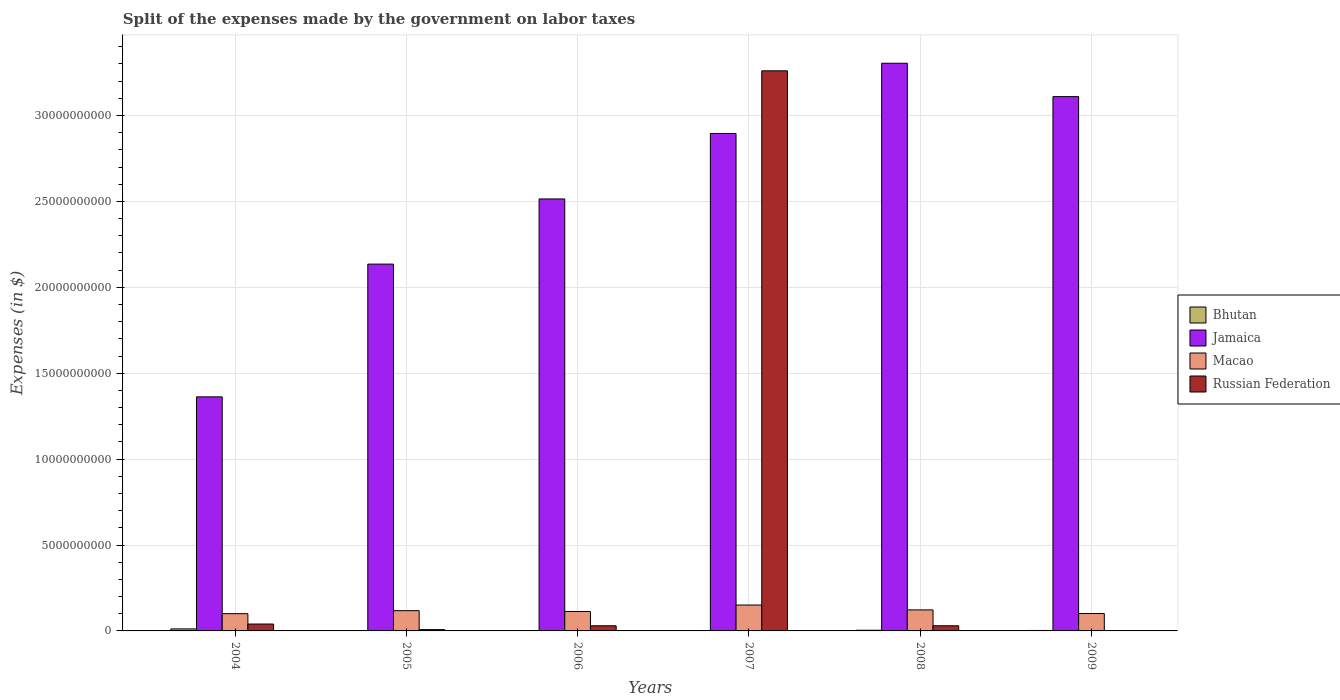Are the number of bars on each tick of the X-axis equal?
Ensure brevity in your answer.  No. What is the expenses made by the government on labor taxes in Jamaica in 2006?
Offer a terse response. 2.51e+1. Across all years, what is the maximum expenses made by the government on labor taxes in Jamaica?
Give a very brief answer. 3.30e+1. Across all years, what is the minimum expenses made by the government on labor taxes in Macao?
Keep it short and to the point. 1.00e+09. In which year was the expenses made by the government on labor taxes in Macao maximum?
Your response must be concise. 2007. What is the total expenses made by the government on labor taxes in Bhutan in the graph?
Ensure brevity in your answer.  2.32e+08. What is the difference between the expenses made by the government on labor taxes in Bhutan in 2004 and that in 2006?
Provide a short and direct response. 1.05e+08. What is the difference between the expenses made by the government on labor taxes in Russian Federation in 2007 and the expenses made by the government on labor taxes in Macao in 2008?
Keep it short and to the point. 3.14e+1. What is the average expenses made by the government on labor taxes in Russian Federation per year?
Provide a short and direct response. 5.61e+09. In the year 2004, what is the difference between the expenses made by the government on labor taxes in Bhutan and expenses made by the government on labor taxes in Jamaica?
Keep it short and to the point. -1.35e+1. In how many years, is the expenses made by the government on labor taxes in Macao greater than 28000000000 $?
Make the answer very short. 0. What is the ratio of the expenses made by the government on labor taxes in Macao in 2004 to that in 2009?
Your response must be concise. 0.99. Is the expenses made by the government on labor taxes in Jamaica in 2005 less than that in 2008?
Offer a very short reply. Yes. What is the difference between the highest and the second highest expenses made by the government on labor taxes in Macao?
Offer a very short reply. 2.83e+08. What is the difference between the highest and the lowest expenses made by the government on labor taxes in Jamaica?
Provide a short and direct response. 1.94e+1. Is it the case that in every year, the sum of the expenses made by the government on labor taxes in Bhutan and expenses made by the government on labor taxes in Macao is greater than the expenses made by the government on labor taxes in Jamaica?
Keep it short and to the point. No. How many bars are there?
Offer a very short reply. 23. Are all the bars in the graph horizontal?
Provide a succinct answer. No. How many years are there in the graph?
Offer a very short reply. 6. What is the difference between two consecutive major ticks on the Y-axis?
Your answer should be compact. 5.00e+09. How are the legend labels stacked?
Give a very brief answer. Vertical. What is the title of the graph?
Provide a succinct answer. Split of the expenses made by the government on labor taxes. Does "Dominica" appear as one of the legend labels in the graph?
Offer a very short reply. No. What is the label or title of the Y-axis?
Provide a succinct answer. Expenses (in $). What is the Expenses (in $) in Bhutan in 2004?
Keep it short and to the point. 1.18e+08. What is the Expenses (in $) of Jamaica in 2004?
Make the answer very short. 1.36e+1. What is the Expenses (in $) in Macao in 2004?
Your answer should be compact. 1.00e+09. What is the Expenses (in $) in Russian Federation in 2004?
Provide a short and direct response. 4.01e+08. What is the Expenses (in $) of Bhutan in 2005?
Keep it short and to the point. 1.28e+07. What is the Expenses (in $) of Jamaica in 2005?
Give a very brief answer. 2.14e+1. What is the Expenses (in $) in Macao in 2005?
Give a very brief answer. 1.18e+09. What is the Expenses (in $) in Russian Federation in 2005?
Offer a very short reply. 7.50e+07. What is the Expenses (in $) in Bhutan in 2006?
Your response must be concise. 1.35e+07. What is the Expenses (in $) of Jamaica in 2006?
Offer a terse response. 2.51e+1. What is the Expenses (in $) in Macao in 2006?
Provide a short and direct response. 1.13e+09. What is the Expenses (in $) of Russian Federation in 2006?
Your response must be concise. 3.00e+08. What is the Expenses (in $) of Bhutan in 2007?
Offer a terse response. 2.20e+07. What is the Expenses (in $) in Jamaica in 2007?
Offer a very short reply. 2.90e+1. What is the Expenses (in $) in Macao in 2007?
Your answer should be compact. 1.51e+09. What is the Expenses (in $) of Russian Federation in 2007?
Offer a terse response. 3.26e+1. What is the Expenses (in $) in Bhutan in 2008?
Keep it short and to the point. 3.87e+07. What is the Expenses (in $) of Jamaica in 2008?
Make the answer very short. 3.30e+1. What is the Expenses (in $) in Macao in 2008?
Your answer should be very brief. 1.22e+09. What is the Expenses (in $) of Russian Federation in 2008?
Ensure brevity in your answer.  3.00e+08. What is the Expenses (in $) in Bhutan in 2009?
Give a very brief answer. 2.65e+07. What is the Expenses (in $) of Jamaica in 2009?
Your response must be concise. 3.11e+1. What is the Expenses (in $) of Macao in 2009?
Offer a terse response. 1.01e+09. What is the Expenses (in $) of Russian Federation in 2009?
Offer a terse response. 0. Across all years, what is the maximum Expenses (in $) of Bhutan?
Make the answer very short. 1.18e+08. Across all years, what is the maximum Expenses (in $) in Jamaica?
Give a very brief answer. 3.30e+1. Across all years, what is the maximum Expenses (in $) in Macao?
Your answer should be very brief. 1.51e+09. Across all years, what is the maximum Expenses (in $) of Russian Federation?
Keep it short and to the point. 3.26e+1. Across all years, what is the minimum Expenses (in $) of Bhutan?
Offer a very short reply. 1.28e+07. Across all years, what is the minimum Expenses (in $) of Jamaica?
Make the answer very short. 1.36e+1. Across all years, what is the minimum Expenses (in $) in Macao?
Offer a very short reply. 1.00e+09. Across all years, what is the minimum Expenses (in $) of Russian Federation?
Your answer should be very brief. 0. What is the total Expenses (in $) of Bhutan in the graph?
Keep it short and to the point. 2.32e+08. What is the total Expenses (in $) of Jamaica in the graph?
Provide a succinct answer. 1.53e+11. What is the total Expenses (in $) of Macao in the graph?
Keep it short and to the point. 7.06e+09. What is the total Expenses (in $) in Russian Federation in the graph?
Your answer should be very brief. 3.37e+1. What is the difference between the Expenses (in $) in Bhutan in 2004 and that in 2005?
Offer a terse response. 1.05e+08. What is the difference between the Expenses (in $) of Jamaica in 2004 and that in 2005?
Your response must be concise. -7.73e+09. What is the difference between the Expenses (in $) of Macao in 2004 and that in 2005?
Provide a short and direct response. -1.74e+08. What is the difference between the Expenses (in $) in Russian Federation in 2004 and that in 2005?
Provide a succinct answer. 3.26e+08. What is the difference between the Expenses (in $) in Bhutan in 2004 and that in 2006?
Provide a short and direct response. 1.05e+08. What is the difference between the Expenses (in $) of Jamaica in 2004 and that in 2006?
Provide a short and direct response. -1.15e+1. What is the difference between the Expenses (in $) of Macao in 2004 and that in 2006?
Ensure brevity in your answer.  -1.26e+08. What is the difference between the Expenses (in $) of Russian Federation in 2004 and that in 2006?
Give a very brief answer. 1.01e+08. What is the difference between the Expenses (in $) of Bhutan in 2004 and that in 2007?
Your answer should be very brief. 9.61e+07. What is the difference between the Expenses (in $) of Jamaica in 2004 and that in 2007?
Give a very brief answer. -1.53e+1. What is the difference between the Expenses (in $) of Macao in 2004 and that in 2007?
Your response must be concise. -5.03e+08. What is the difference between the Expenses (in $) in Russian Federation in 2004 and that in 2007?
Make the answer very short. -3.22e+1. What is the difference between the Expenses (in $) of Bhutan in 2004 and that in 2008?
Offer a very short reply. 7.95e+07. What is the difference between the Expenses (in $) of Jamaica in 2004 and that in 2008?
Keep it short and to the point. -1.94e+1. What is the difference between the Expenses (in $) of Macao in 2004 and that in 2008?
Give a very brief answer. -2.19e+08. What is the difference between the Expenses (in $) in Russian Federation in 2004 and that in 2008?
Provide a short and direct response. 1.01e+08. What is the difference between the Expenses (in $) of Bhutan in 2004 and that in 2009?
Make the answer very short. 9.17e+07. What is the difference between the Expenses (in $) in Jamaica in 2004 and that in 2009?
Your answer should be compact. -1.75e+1. What is the difference between the Expenses (in $) in Macao in 2004 and that in 2009?
Provide a short and direct response. -8.64e+06. What is the difference between the Expenses (in $) in Bhutan in 2005 and that in 2006?
Keep it short and to the point. -6.82e+05. What is the difference between the Expenses (in $) in Jamaica in 2005 and that in 2006?
Your answer should be very brief. -3.79e+09. What is the difference between the Expenses (in $) of Macao in 2005 and that in 2006?
Offer a terse response. 4.80e+07. What is the difference between the Expenses (in $) in Russian Federation in 2005 and that in 2006?
Your response must be concise. -2.25e+08. What is the difference between the Expenses (in $) in Bhutan in 2005 and that in 2007?
Ensure brevity in your answer.  -9.28e+06. What is the difference between the Expenses (in $) of Jamaica in 2005 and that in 2007?
Provide a succinct answer. -7.60e+09. What is the difference between the Expenses (in $) of Macao in 2005 and that in 2007?
Give a very brief answer. -3.28e+08. What is the difference between the Expenses (in $) of Russian Federation in 2005 and that in 2007?
Ensure brevity in your answer.  -3.25e+1. What is the difference between the Expenses (in $) in Bhutan in 2005 and that in 2008?
Your answer should be very brief. -2.59e+07. What is the difference between the Expenses (in $) in Jamaica in 2005 and that in 2008?
Keep it short and to the point. -1.17e+1. What is the difference between the Expenses (in $) of Macao in 2005 and that in 2008?
Keep it short and to the point. -4.48e+07. What is the difference between the Expenses (in $) of Russian Federation in 2005 and that in 2008?
Your answer should be compact. -2.25e+08. What is the difference between the Expenses (in $) in Bhutan in 2005 and that in 2009?
Provide a succinct answer. -1.37e+07. What is the difference between the Expenses (in $) of Jamaica in 2005 and that in 2009?
Keep it short and to the point. -9.75e+09. What is the difference between the Expenses (in $) of Macao in 2005 and that in 2009?
Offer a very short reply. 1.66e+08. What is the difference between the Expenses (in $) in Bhutan in 2006 and that in 2007?
Offer a very short reply. -8.59e+06. What is the difference between the Expenses (in $) in Jamaica in 2006 and that in 2007?
Ensure brevity in your answer.  -3.81e+09. What is the difference between the Expenses (in $) in Macao in 2006 and that in 2007?
Your answer should be very brief. -3.76e+08. What is the difference between the Expenses (in $) in Russian Federation in 2006 and that in 2007?
Ensure brevity in your answer.  -3.23e+1. What is the difference between the Expenses (in $) in Bhutan in 2006 and that in 2008?
Your answer should be compact. -2.52e+07. What is the difference between the Expenses (in $) of Jamaica in 2006 and that in 2008?
Your answer should be very brief. -7.90e+09. What is the difference between the Expenses (in $) in Macao in 2006 and that in 2008?
Your response must be concise. -9.28e+07. What is the difference between the Expenses (in $) in Bhutan in 2006 and that in 2009?
Your answer should be very brief. -1.30e+07. What is the difference between the Expenses (in $) of Jamaica in 2006 and that in 2009?
Your answer should be very brief. -5.96e+09. What is the difference between the Expenses (in $) of Macao in 2006 and that in 2009?
Give a very brief answer. 1.18e+08. What is the difference between the Expenses (in $) of Bhutan in 2007 and that in 2008?
Offer a terse response. -1.66e+07. What is the difference between the Expenses (in $) of Jamaica in 2007 and that in 2008?
Your answer should be compact. -4.09e+09. What is the difference between the Expenses (in $) in Macao in 2007 and that in 2008?
Your response must be concise. 2.83e+08. What is the difference between the Expenses (in $) of Russian Federation in 2007 and that in 2008?
Give a very brief answer. 3.23e+1. What is the difference between the Expenses (in $) in Bhutan in 2007 and that in 2009?
Ensure brevity in your answer.  -4.44e+06. What is the difference between the Expenses (in $) in Jamaica in 2007 and that in 2009?
Provide a succinct answer. -2.14e+09. What is the difference between the Expenses (in $) of Macao in 2007 and that in 2009?
Offer a terse response. 4.94e+08. What is the difference between the Expenses (in $) of Bhutan in 2008 and that in 2009?
Your answer should be very brief. 1.22e+07. What is the difference between the Expenses (in $) of Jamaica in 2008 and that in 2009?
Ensure brevity in your answer.  1.94e+09. What is the difference between the Expenses (in $) in Macao in 2008 and that in 2009?
Provide a succinct answer. 2.11e+08. What is the difference between the Expenses (in $) in Bhutan in 2004 and the Expenses (in $) in Jamaica in 2005?
Ensure brevity in your answer.  -2.12e+1. What is the difference between the Expenses (in $) in Bhutan in 2004 and the Expenses (in $) in Macao in 2005?
Your answer should be compact. -1.06e+09. What is the difference between the Expenses (in $) in Bhutan in 2004 and the Expenses (in $) in Russian Federation in 2005?
Ensure brevity in your answer.  4.32e+07. What is the difference between the Expenses (in $) in Jamaica in 2004 and the Expenses (in $) in Macao in 2005?
Your answer should be compact. 1.24e+1. What is the difference between the Expenses (in $) of Jamaica in 2004 and the Expenses (in $) of Russian Federation in 2005?
Your response must be concise. 1.35e+1. What is the difference between the Expenses (in $) of Macao in 2004 and the Expenses (in $) of Russian Federation in 2005?
Ensure brevity in your answer.  9.30e+08. What is the difference between the Expenses (in $) in Bhutan in 2004 and the Expenses (in $) in Jamaica in 2006?
Make the answer very short. -2.50e+1. What is the difference between the Expenses (in $) in Bhutan in 2004 and the Expenses (in $) in Macao in 2006?
Your response must be concise. -1.01e+09. What is the difference between the Expenses (in $) in Bhutan in 2004 and the Expenses (in $) in Russian Federation in 2006?
Offer a terse response. -1.82e+08. What is the difference between the Expenses (in $) of Jamaica in 2004 and the Expenses (in $) of Macao in 2006?
Provide a succinct answer. 1.25e+1. What is the difference between the Expenses (in $) of Jamaica in 2004 and the Expenses (in $) of Russian Federation in 2006?
Offer a terse response. 1.33e+1. What is the difference between the Expenses (in $) of Macao in 2004 and the Expenses (in $) of Russian Federation in 2006?
Give a very brief answer. 7.05e+08. What is the difference between the Expenses (in $) of Bhutan in 2004 and the Expenses (in $) of Jamaica in 2007?
Ensure brevity in your answer.  -2.88e+1. What is the difference between the Expenses (in $) in Bhutan in 2004 and the Expenses (in $) in Macao in 2007?
Offer a terse response. -1.39e+09. What is the difference between the Expenses (in $) in Bhutan in 2004 and the Expenses (in $) in Russian Federation in 2007?
Your answer should be compact. -3.25e+1. What is the difference between the Expenses (in $) of Jamaica in 2004 and the Expenses (in $) of Macao in 2007?
Your answer should be very brief. 1.21e+1. What is the difference between the Expenses (in $) in Jamaica in 2004 and the Expenses (in $) in Russian Federation in 2007?
Give a very brief answer. -1.90e+1. What is the difference between the Expenses (in $) of Macao in 2004 and the Expenses (in $) of Russian Federation in 2007?
Provide a succinct answer. -3.16e+1. What is the difference between the Expenses (in $) in Bhutan in 2004 and the Expenses (in $) in Jamaica in 2008?
Provide a succinct answer. -3.29e+1. What is the difference between the Expenses (in $) in Bhutan in 2004 and the Expenses (in $) in Macao in 2008?
Provide a short and direct response. -1.11e+09. What is the difference between the Expenses (in $) in Bhutan in 2004 and the Expenses (in $) in Russian Federation in 2008?
Offer a terse response. -1.82e+08. What is the difference between the Expenses (in $) of Jamaica in 2004 and the Expenses (in $) of Macao in 2008?
Provide a short and direct response. 1.24e+1. What is the difference between the Expenses (in $) of Jamaica in 2004 and the Expenses (in $) of Russian Federation in 2008?
Offer a very short reply. 1.33e+1. What is the difference between the Expenses (in $) in Macao in 2004 and the Expenses (in $) in Russian Federation in 2008?
Your answer should be very brief. 7.05e+08. What is the difference between the Expenses (in $) in Bhutan in 2004 and the Expenses (in $) in Jamaica in 2009?
Provide a short and direct response. -3.10e+1. What is the difference between the Expenses (in $) in Bhutan in 2004 and the Expenses (in $) in Macao in 2009?
Offer a terse response. -8.95e+08. What is the difference between the Expenses (in $) in Jamaica in 2004 and the Expenses (in $) in Macao in 2009?
Make the answer very short. 1.26e+1. What is the difference between the Expenses (in $) of Bhutan in 2005 and the Expenses (in $) of Jamaica in 2006?
Your answer should be very brief. -2.51e+1. What is the difference between the Expenses (in $) of Bhutan in 2005 and the Expenses (in $) of Macao in 2006?
Offer a terse response. -1.12e+09. What is the difference between the Expenses (in $) of Bhutan in 2005 and the Expenses (in $) of Russian Federation in 2006?
Ensure brevity in your answer.  -2.87e+08. What is the difference between the Expenses (in $) of Jamaica in 2005 and the Expenses (in $) of Macao in 2006?
Offer a terse response. 2.02e+1. What is the difference between the Expenses (in $) in Jamaica in 2005 and the Expenses (in $) in Russian Federation in 2006?
Give a very brief answer. 2.11e+1. What is the difference between the Expenses (in $) in Macao in 2005 and the Expenses (in $) in Russian Federation in 2006?
Offer a very short reply. 8.79e+08. What is the difference between the Expenses (in $) in Bhutan in 2005 and the Expenses (in $) in Jamaica in 2007?
Ensure brevity in your answer.  -2.89e+1. What is the difference between the Expenses (in $) of Bhutan in 2005 and the Expenses (in $) of Macao in 2007?
Your response must be concise. -1.49e+09. What is the difference between the Expenses (in $) in Bhutan in 2005 and the Expenses (in $) in Russian Federation in 2007?
Give a very brief answer. -3.26e+1. What is the difference between the Expenses (in $) in Jamaica in 2005 and the Expenses (in $) in Macao in 2007?
Provide a succinct answer. 1.98e+1. What is the difference between the Expenses (in $) in Jamaica in 2005 and the Expenses (in $) in Russian Federation in 2007?
Provide a short and direct response. -1.12e+1. What is the difference between the Expenses (in $) in Macao in 2005 and the Expenses (in $) in Russian Federation in 2007?
Make the answer very short. -3.14e+1. What is the difference between the Expenses (in $) of Bhutan in 2005 and the Expenses (in $) of Jamaica in 2008?
Offer a terse response. -3.30e+1. What is the difference between the Expenses (in $) of Bhutan in 2005 and the Expenses (in $) of Macao in 2008?
Keep it short and to the point. -1.21e+09. What is the difference between the Expenses (in $) of Bhutan in 2005 and the Expenses (in $) of Russian Federation in 2008?
Offer a very short reply. -2.87e+08. What is the difference between the Expenses (in $) in Jamaica in 2005 and the Expenses (in $) in Macao in 2008?
Keep it short and to the point. 2.01e+1. What is the difference between the Expenses (in $) of Jamaica in 2005 and the Expenses (in $) of Russian Federation in 2008?
Offer a very short reply. 2.11e+1. What is the difference between the Expenses (in $) in Macao in 2005 and the Expenses (in $) in Russian Federation in 2008?
Keep it short and to the point. 8.79e+08. What is the difference between the Expenses (in $) of Bhutan in 2005 and the Expenses (in $) of Jamaica in 2009?
Your answer should be very brief. -3.11e+1. What is the difference between the Expenses (in $) in Bhutan in 2005 and the Expenses (in $) in Macao in 2009?
Offer a very short reply. -1.00e+09. What is the difference between the Expenses (in $) of Jamaica in 2005 and the Expenses (in $) of Macao in 2009?
Offer a terse response. 2.03e+1. What is the difference between the Expenses (in $) of Bhutan in 2006 and the Expenses (in $) of Jamaica in 2007?
Your answer should be compact. -2.89e+1. What is the difference between the Expenses (in $) in Bhutan in 2006 and the Expenses (in $) in Macao in 2007?
Make the answer very short. -1.49e+09. What is the difference between the Expenses (in $) of Bhutan in 2006 and the Expenses (in $) of Russian Federation in 2007?
Your answer should be very brief. -3.26e+1. What is the difference between the Expenses (in $) in Jamaica in 2006 and the Expenses (in $) in Macao in 2007?
Provide a short and direct response. 2.36e+1. What is the difference between the Expenses (in $) in Jamaica in 2006 and the Expenses (in $) in Russian Federation in 2007?
Provide a succinct answer. -7.46e+09. What is the difference between the Expenses (in $) in Macao in 2006 and the Expenses (in $) in Russian Federation in 2007?
Provide a short and direct response. -3.15e+1. What is the difference between the Expenses (in $) of Bhutan in 2006 and the Expenses (in $) of Jamaica in 2008?
Your answer should be compact. -3.30e+1. What is the difference between the Expenses (in $) of Bhutan in 2006 and the Expenses (in $) of Macao in 2008?
Keep it short and to the point. -1.21e+09. What is the difference between the Expenses (in $) in Bhutan in 2006 and the Expenses (in $) in Russian Federation in 2008?
Your response must be concise. -2.87e+08. What is the difference between the Expenses (in $) in Jamaica in 2006 and the Expenses (in $) in Macao in 2008?
Give a very brief answer. 2.39e+1. What is the difference between the Expenses (in $) in Jamaica in 2006 and the Expenses (in $) in Russian Federation in 2008?
Offer a very short reply. 2.48e+1. What is the difference between the Expenses (in $) in Macao in 2006 and the Expenses (in $) in Russian Federation in 2008?
Ensure brevity in your answer.  8.31e+08. What is the difference between the Expenses (in $) of Bhutan in 2006 and the Expenses (in $) of Jamaica in 2009?
Provide a succinct answer. -3.11e+1. What is the difference between the Expenses (in $) in Bhutan in 2006 and the Expenses (in $) in Macao in 2009?
Offer a very short reply. -1.00e+09. What is the difference between the Expenses (in $) of Jamaica in 2006 and the Expenses (in $) of Macao in 2009?
Provide a succinct answer. 2.41e+1. What is the difference between the Expenses (in $) in Bhutan in 2007 and the Expenses (in $) in Jamaica in 2008?
Your answer should be very brief. -3.30e+1. What is the difference between the Expenses (in $) of Bhutan in 2007 and the Expenses (in $) of Macao in 2008?
Your answer should be compact. -1.20e+09. What is the difference between the Expenses (in $) of Bhutan in 2007 and the Expenses (in $) of Russian Federation in 2008?
Offer a very short reply. -2.78e+08. What is the difference between the Expenses (in $) of Jamaica in 2007 and the Expenses (in $) of Macao in 2008?
Offer a very short reply. 2.77e+1. What is the difference between the Expenses (in $) of Jamaica in 2007 and the Expenses (in $) of Russian Federation in 2008?
Provide a short and direct response. 2.87e+1. What is the difference between the Expenses (in $) of Macao in 2007 and the Expenses (in $) of Russian Federation in 2008?
Your answer should be very brief. 1.21e+09. What is the difference between the Expenses (in $) in Bhutan in 2007 and the Expenses (in $) in Jamaica in 2009?
Give a very brief answer. -3.11e+1. What is the difference between the Expenses (in $) of Bhutan in 2007 and the Expenses (in $) of Macao in 2009?
Keep it short and to the point. -9.91e+08. What is the difference between the Expenses (in $) of Jamaica in 2007 and the Expenses (in $) of Macao in 2009?
Your response must be concise. 2.79e+1. What is the difference between the Expenses (in $) in Bhutan in 2008 and the Expenses (in $) in Jamaica in 2009?
Ensure brevity in your answer.  -3.11e+1. What is the difference between the Expenses (in $) in Bhutan in 2008 and the Expenses (in $) in Macao in 2009?
Your answer should be very brief. -9.75e+08. What is the difference between the Expenses (in $) of Jamaica in 2008 and the Expenses (in $) of Macao in 2009?
Provide a succinct answer. 3.20e+1. What is the average Expenses (in $) of Bhutan per year?
Make the answer very short. 3.86e+07. What is the average Expenses (in $) of Jamaica per year?
Offer a very short reply. 2.55e+1. What is the average Expenses (in $) in Macao per year?
Offer a very short reply. 1.18e+09. What is the average Expenses (in $) of Russian Federation per year?
Offer a very short reply. 5.61e+09. In the year 2004, what is the difference between the Expenses (in $) of Bhutan and Expenses (in $) of Jamaica?
Give a very brief answer. -1.35e+1. In the year 2004, what is the difference between the Expenses (in $) of Bhutan and Expenses (in $) of Macao?
Make the answer very short. -8.86e+08. In the year 2004, what is the difference between the Expenses (in $) in Bhutan and Expenses (in $) in Russian Federation?
Ensure brevity in your answer.  -2.83e+08. In the year 2004, what is the difference between the Expenses (in $) of Jamaica and Expenses (in $) of Macao?
Your response must be concise. 1.26e+1. In the year 2004, what is the difference between the Expenses (in $) in Jamaica and Expenses (in $) in Russian Federation?
Ensure brevity in your answer.  1.32e+1. In the year 2004, what is the difference between the Expenses (in $) in Macao and Expenses (in $) in Russian Federation?
Offer a very short reply. 6.04e+08. In the year 2005, what is the difference between the Expenses (in $) of Bhutan and Expenses (in $) of Jamaica?
Your response must be concise. -2.13e+1. In the year 2005, what is the difference between the Expenses (in $) in Bhutan and Expenses (in $) in Macao?
Your answer should be compact. -1.17e+09. In the year 2005, what is the difference between the Expenses (in $) of Bhutan and Expenses (in $) of Russian Federation?
Make the answer very short. -6.22e+07. In the year 2005, what is the difference between the Expenses (in $) of Jamaica and Expenses (in $) of Macao?
Your response must be concise. 2.02e+1. In the year 2005, what is the difference between the Expenses (in $) of Jamaica and Expenses (in $) of Russian Federation?
Your answer should be compact. 2.13e+1. In the year 2005, what is the difference between the Expenses (in $) in Macao and Expenses (in $) in Russian Federation?
Make the answer very short. 1.10e+09. In the year 2006, what is the difference between the Expenses (in $) in Bhutan and Expenses (in $) in Jamaica?
Offer a terse response. -2.51e+1. In the year 2006, what is the difference between the Expenses (in $) in Bhutan and Expenses (in $) in Macao?
Ensure brevity in your answer.  -1.12e+09. In the year 2006, what is the difference between the Expenses (in $) in Bhutan and Expenses (in $) in Russian Federation?
Give a very brief answer. -2.87e+08. In the year 2006, what is the difference between the Expenses (in $) in Jamaica and Expenses (in $) in Macao?
Provide a short and direct response. 2.40e+1. In the year 2006, what is the difference between the Expenses (in $) of Jamaica and Expenses (in $) of Russian Federation?
Provide a succinct answer. 2.48e+1. In the year 2006, what is the difference between the Expenses (in $) of Macao and Expenses (in $) of Russian Federation?
Make the answer very short. 8.31e+08. In the year 2007, what is the difference between the Expenses (in $) of Bhutan and Expenses (in $) of Jamaica?
Your answer should be compact. -2.89e+1. In the year 2007, what is the difference between the Expenses (in $) of Bhutan and Expenses (in $) of Macao?
Provide a short and direct response. -1.49e+09. In the year 2007, what is the difference between the Expenses (in $) of Bhutan and Expenses (in $) of Russian Federation?
Keep it short and to the point. -3.26e+1. In the year 2007, what is the difference between the Expenses (in $) of Jamaica and Expenses (in $) of Macao?
Keep it short and to the point. 2.74e+1. In the year 2007, what is the difference between the Expenses (in $) in Jamaica and Expenses (in $) in Russian Federation?
Make the answer very short. -3.65e+09. In the year 2007, what is the difference between the Expenses (in $) in Macao and Expenses (in $) in Russian Federation?
Make the answer very short. -3.11e+1. In the year 2008, what is the difference between the Expenses (in $) in Bhutan and Expenses (in $) in Jamaica?
Give a very brief answer. -3.30e+1. In the year 2008, what is the difference between the Expenses (in $) in Bhutan and Expenses (in $) in Macao?
Offer a very short reply. -1.19e+09. In the year 2008, what is the difference between the Expenses (in $) of Bhutan and Expenses (in $) of Russian Federation?
Offer a terse response. -2.61e+08. In the year 2008, what is the difference between the Expenses (in $) in Jamaica and Expenses (in $) in Macao?
Your answer should be compact. 3.18e+1. In the year 2008, what is the difference between the Expenses (in $) in Jamaica and Expenses (in $) in Russian Federation?
Your answer should be very brief. 3.27e+1. In the year 2008, what is the difference between the Expenses (in $) in Macao and Expenses (in $) in Russian Federation?
Provide a succinct answer. 9.24e+08. In the year 2009, what is the difference between the Expenses (in $) in Bhutan and Expenses (in $) in Jamaica?
Your answer should be very brief. -3.11e+1. In the year 2009, what is the difference between the Expenses (in $) in Bhutan and Expenses (in $) in Macao?
Your response must be concise. -9.87e+08. In the year 2009, what is the difference between the Expenses (in $) of Jamaica and Expenses (in $) of Macao?
Provide a short and direct response. 3.01e+1. What is the ratio of the Expenses (in $) of Bhutan in 2004 to that in 2005?
Offer a very short reply. 9.25. What is the ratio of the Expenses (in $) in Jamaica in 2004 to that in 2005?
Ensure brevity in your answer.  0.64. What is the ratio of the Expenses (in $) of Macao in 2004 to that in 2005?
Offer a very short reply. 0.85. What is the ratio of the Expenses (in $) of Russian Federation in 2004 to that in 2005?
Offer a terse response. 5.34. What is the ratio of the Expenses (in $) in Bhutan in 2004 to that in 2006?
Offer a very short reply. 8.78. What is the ratio of the Expenses (in $) in Jamaica in 2004 to that in 2006?
Give a very brief answer. 0.54. What is the ratio of the Expenses (in $) in Macao in 2004 to that in 2006?
Make the answer very short. 0.89. What is the ratio of the Expenses (in $) in Russian Federation in 2004 to that in 2006?
Provide a short and direct response. 1.34. What is the ratio of the Expenses (in $) of Bhutan in 2004 to that in 2007?
Keep it short and to the point. 5.36. What is the ratio of the Expenses (in $) in Jamaica in 2004 to that in 2007?
Offer a very short reply. 0.47. What is the ratio of the Expenses (in $) in Macao in 2004 to that in 2007?
Ensure brevity in your answer.  0.67. What is the ratio of the Expenses (in $) in Russian Federation in 2004 to that in 2007?
Provide a succinct answer. 0.01. What is the ratio of the Expenses (in $) of Bhutan in 2004 to that in 2008?
Provide a succinct answer. 3.06. What is the ratio of the Expenses (in $) in Jamaica in 2004 to that in 2008?
Ensure brevity in your answer.  0.41. What is the ratio of the Expenses (in $) in Macao in 2004 to that in 2008?
Ensure brevity in your answer.  0.82. What is the ratio of the Expenses (in $) of Russian Federation in 2004 to that in 2008?
Your response must be concise. 1.34. What is the ratio of the Expenses (in $) of Bhutan in 2004 to that in 2009?
Your answer should be compact. 4.46. What is the ratio of the Expenses (in $) of Jamaica in 2004 to that in 2009?
Offer a very short reply. 0.44. What is the ratio of the Expenses (in $) of Macao in 2004 to that in 2009?
Keep it short and to the point. 0.99. What is the ratio of the Expenses (in $) in Bhutan in 2005 to that in 2006?
Your response must be concise. 0.95. What is the ratio of the Expenses (in $) of Jamaica in 2005 to that in 2006?
Your answer should be very brief. 0.85. What is the ratio of the Expenses (in $) of Macao in 2005 to that in 2006?
Ensure brevity in your answer.  1.04. What is the ratio of the Expenses (in $) in Russian Federation in 2005 to that in 2006?
Keep it short and to the point. 0.25. What is the ratio of the Expenses (in $) in Bhutan in 2005 to that in 2007?
Your answer should be very brief. 0.58. What is the ratio of the Expenses (in $) in Jamaica in 2005 to that in 2007?
Provide a succinct answer. 0.74. What is the ratio of the Expenses (in $) of Macao in 2005 to that in 2007?
Offer a terse response. 0.78. What is the ratio of the Expenses (in $) in Russian Federation in 2005 to that in 2007?
Provide a succinct answer. 0. What is the ratio of the Expenses (in $) in Bhutan in 2005 to that in 2008?
Offer a terse response. 0.33. What is the ratio of the Expenses (in $) of Jamaica in 2005 to that in 2008?
Give a very brief answer. 0.65. What is the ratio of the Expenses (in $) in Macao in 2005 to that in 2008?
Offer a terse response. 0.96. What is the ratio of the Expenses (in $) of Bhutan in 2005 to that in 2009?
Offer a terse response. 0.48. What is the ratio of the Expenses (in $) of Jamaica in 2005 to that in 2009?
Your answer should be compact. 0.69. What is the ratio of the Expenses (in $) of Macao in 2005 to that in 2009?
Ensure brevity in your answer.  1.16. What is the ratio of the Expenses (in $) of Bhutan in 2006 to that in 2007?
Your answer should be compact. 0.61. What is the ratio of the Expenses (in $) of Jamaica in 2006 to that in 2007?
Offer a terse response. 0.87. What is the ratio of the Expenses (in $) in Macao in 2006 to that in 2007?
Give a very brief answer. 0.75. What is the ratio of the Expenses (in $) in Russian Federation in 2006 to that in 2007?
Offer a very short reply. 0.01. What is the ratio of the Expenses (in $) of Bhutan in 2006 to that in 2008?
Your answer should be very brief. 0.35. What is the ratio of the Expenses (in $) of Jamaica in 2006 to that in 2008?
Ensure brevity in your answer.  0.76. What is the ratio of the Expenses (in $) of Macao in 2006 to that in 2008?
Your response must be concise. 0.92. What is the ratio of the Expenses (in $) of Bhutan in 2006 to that in 2009?
Your response must be concise. 0.51. What is the ratio of the Expenses (in $) of Jamaica in 2006 to that in 2009?
Give a very brief answer. 0.81. What is the ratio of the Expenses (in $) of Macao in 2006 to that in 2009?
Provide a short and direct response. 1.12. What is the ratio of the Expenses (in $) in Bhutan in 2007 to that in 2008?
Your answer should be compact. 0.57. What is the ratio of the Expenses (in $) in Jamaica in 2007 to that in 2008?
Ensure brevity in your answer.  0.88. What is the ratio of the Expenses (in $) of Macao in 2007 to that in 2008?
Your response must be concise. 1.23. What is the ratio of the Expenses (in $) of Russian Federation in 2007 to that in 2008?
Your response must be concise. 108.67. What is the ratio of the Expenses (in $) in Bhutan in 2007 to that in 2009?
Your response must be concise. 0.83. What is the ratio of the Expenses (in $) of Jamaica in 2007 to that in 2009?
Ensure brevity in your answer.  0.93. What is the ratio of the Expenses (in $) in Macao in 2007 to that in 2009?
Provide a short and direct response. 1.49. What is the ratio of the Expenses (in $) in Bhutan in 2008 to that in 2009?
Your response must be concise. 1.46. What is the ratio of the Expenses (in $) in Jamaica in 2008 to that in 2009?
Make the answer very short. 1.06. What is the ratio of the Expenses (in $) in Macao in 2008 to that in 2009?
Keep it short and to the point. 1.21. What is the difference between the highest and the second highest Expenses (in $) in Bhutan?
Your answer should be compact. 7.95e+07. What is the difference between the highest and the second highest Expenses (in $) in Jamaica?
Provide a short and direct response. 1.94e+09. What is the difference between the highest and the second highest Expenses (in $) of Macao?
Provide a short and direct response. 2.83e+08. What is the difference between the highest and the second highest Expenses (in $) of Russian Federation?
Offer a very short reply. 3.22e+1. What is the difference between the highest and the lowest Expenses (in $) in Bhutan?
Give a very brief answer. 1.05e+08. What is the difference between the highest and the lowest Expenses (in $) of Jamaica?
Offer a terse response. 1.94e+1. What is the difference between the highest and the lowest Expenses (in $) in Macao?
Your answer should be very brief. 5.03e+08. What is the difference between the highest and the lowest Expenses (in $) of Russian Federation?
Make the answer very short. 3.26e+1. 